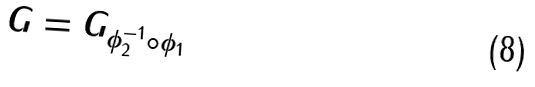<formula> <loc_0><loc_0><loc_500><loc_500>G = G _ { \phi _ { 2 } ^ { - 1 } \circ \phi _ { 1 } }</formula> 